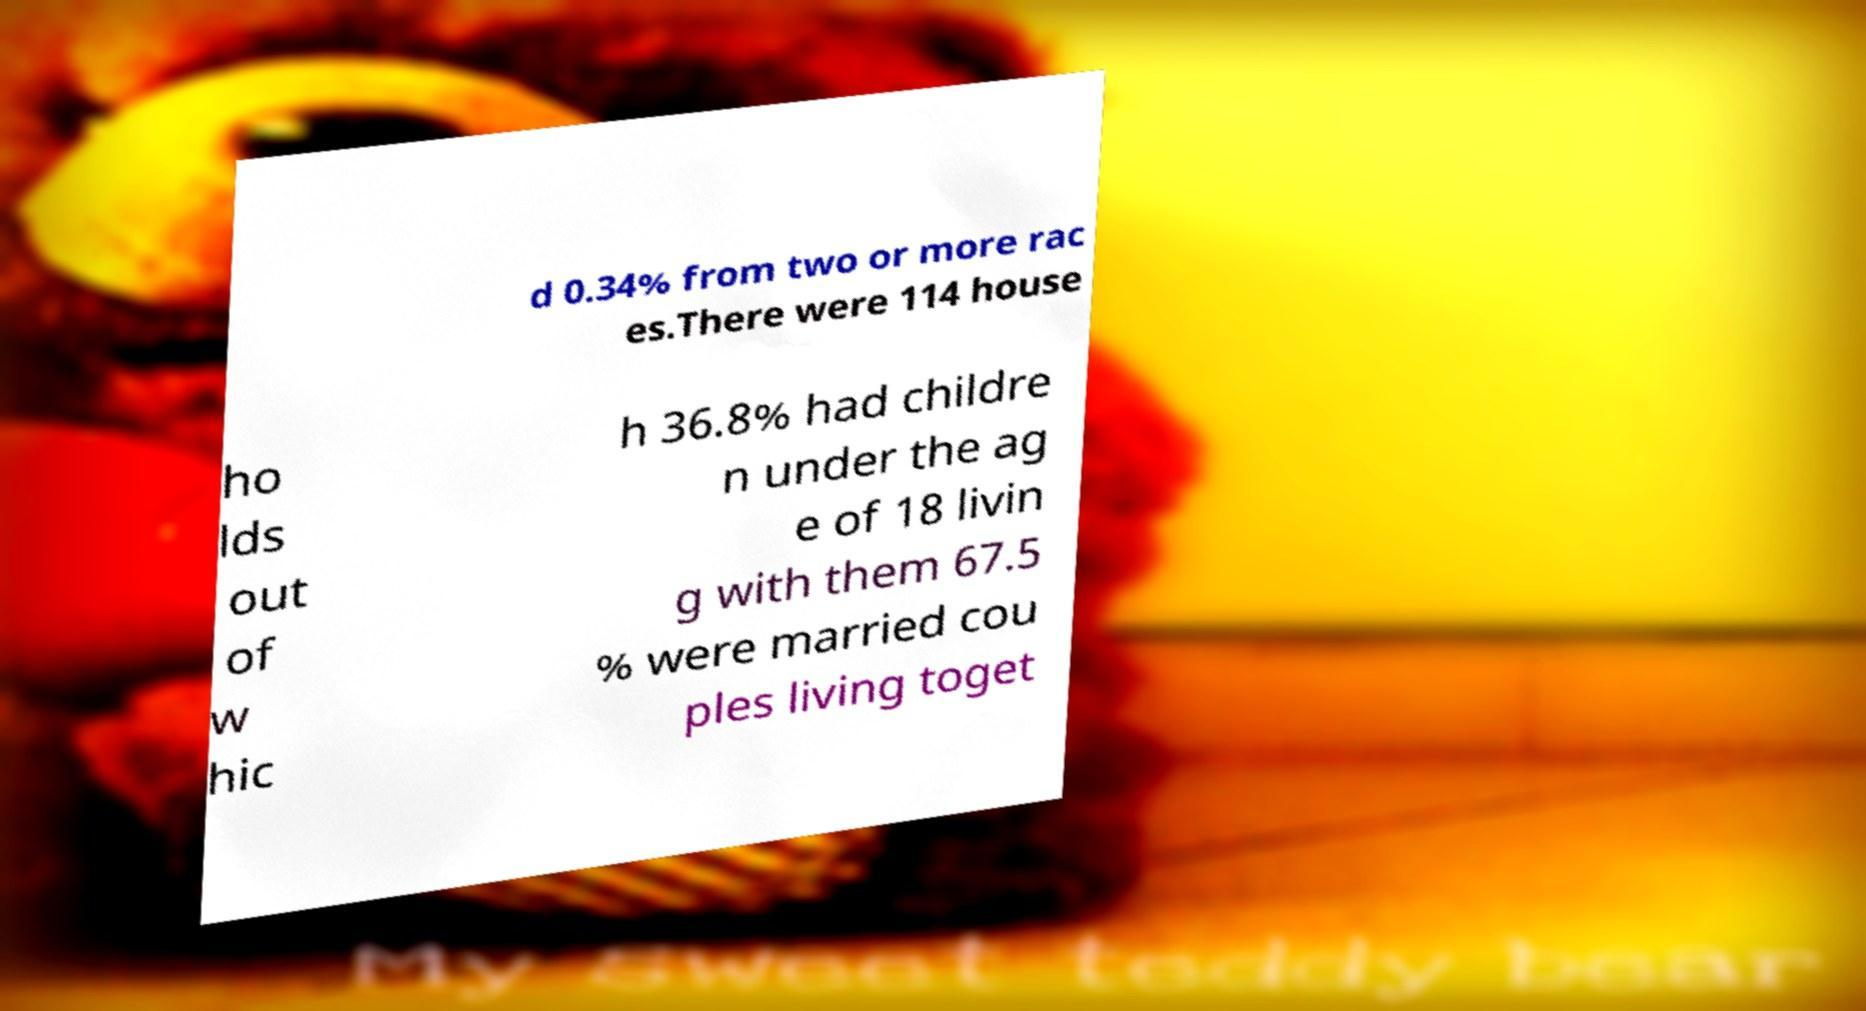Can you read and provide the text displayed in the image?This photo seems to have some interesting text. Can you extract and type it out for me? d 0.34% from two or more rac es.There were 114 house ho lds out of w hic h 36.8% had childre n under the ag e of 18 livin g with them 67.5 % were married cou ples living toget 